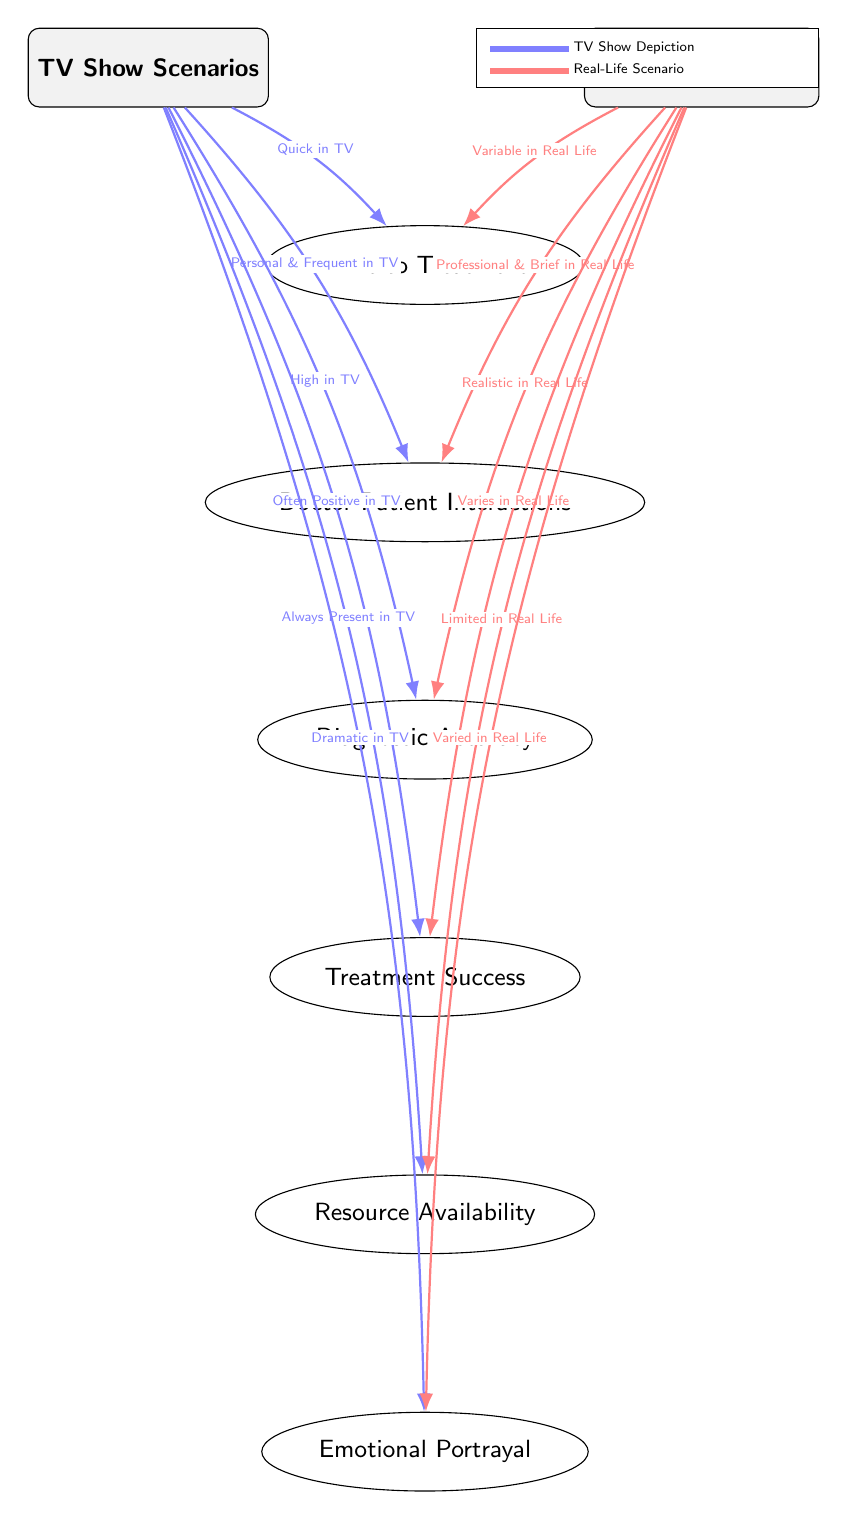What is the first comparison topic under TV Show Scenarios? The first comparison node listed below the 'TV Show Scenarios' node is 'Time to Treatment'. This is determined by looking directly at the arrangement of nodes under 'TV Show Scenarios'.
Answer: Time to Treatment How are the Doctor-Patient Interactions perceived in TV shows compared to real life? The edge from 'TV Show Scenarios' describes Doctor-Patient Interactions as 'Personal & Frequent in TV', while the corresponding edge from 'Real ER Outcomes' notes them as 'Professional & Brief in Real Life'. This comparison clearly illustrates the difference in interaction styles.
Answer: Personal & Frequent in TV; Professional & Brief in Real Life What is the portrayal of resources in TV shows as compared to real-life emergency rooms? In the diagram, 'Resources' under 'TV Show Scenarios' is depicted as 'Always Present', while for 'Real ER Outcomes', it is noted as 'Limited'. This directly compares the availability of resources in both contexts.
Answer: Always Present; Limited How does the treatment success in TV shows contrast with real life outcomes? The 'Treatment Success' node shows 'Often Positive in TV' for TV shows, while it indicates 'Varies in Real Life' for actual emergency room outcomes. This requires analyzing both edges leading to the 'Treatment Success' node.
Answer: Often Positive in TV; Varies in Real Life What is the emotional portrayal in emergency room scenarios on TV compared to real life? The 'Emotional Portrayal' comparison node indicates that it is 'Dramatic in TV' and 'Varied in Real Life', highlighting the difference in how emotions are depicted in the two contexts. To answer this, we look at the edges linked to the 'Emotional Portrayal' node.
Answer: Dramatic in TV; Varied in Real Life Which comparison topic indicates that timing varies in real life compared to TV? The node 'Time to Treatment' specifically addresses timing, with the edge from 'TV Show Scenarios' stating 'Quick in TV', contrasting it with 'Variable in Real Life' as indicated by the edge from 'Real ER Outcomes'.
Answer: Time to Treatment 